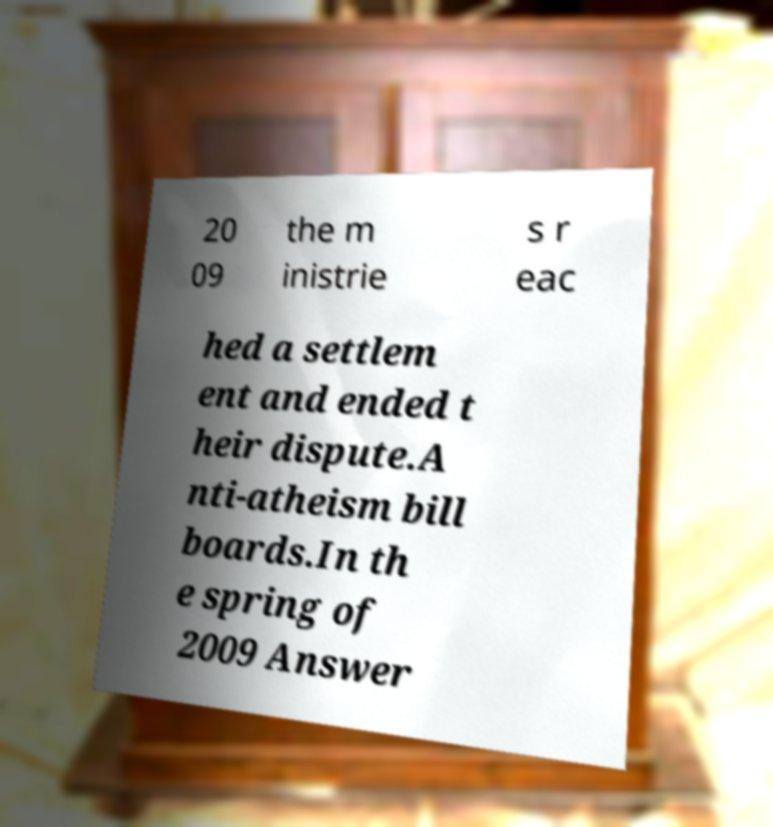There's text embedded in this image that I need extracted. Can you transcribe it verbatim? 20 09 the m inistrie s r eac hed a settlem ent and ended t heir dispute.A nti-atheism bill boards.In th e spring of 2009 Answer 